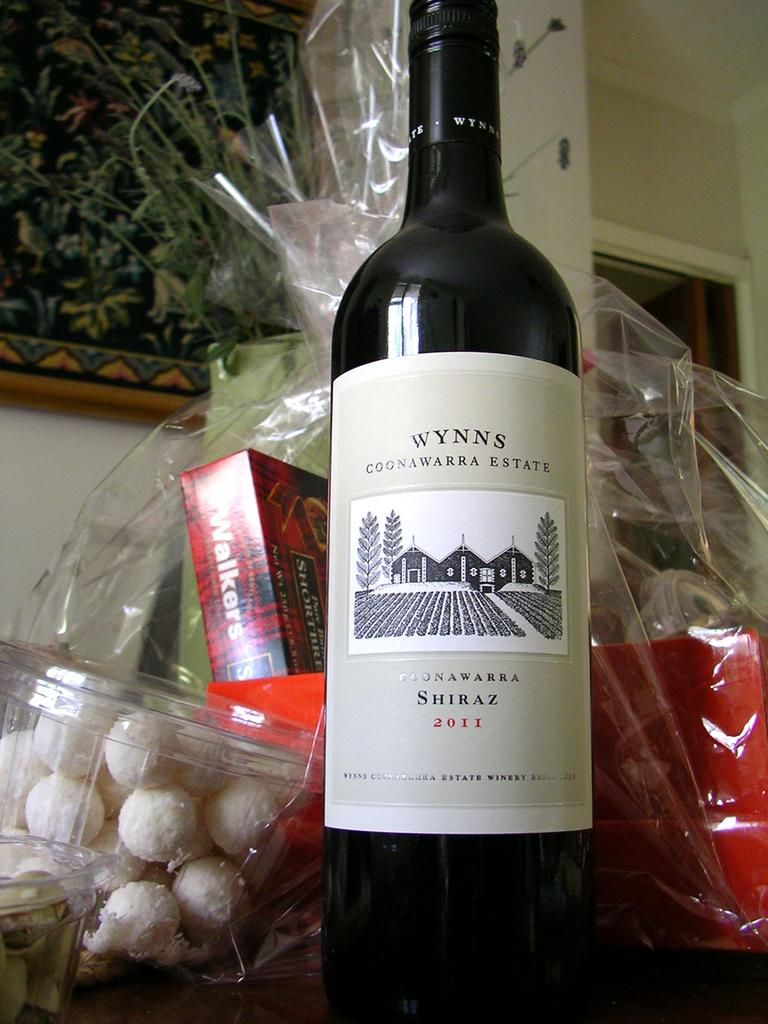<image>
Share a concise interpretation of the image provided. gift basket with a 2011 bottle of wynns shiraz in front 